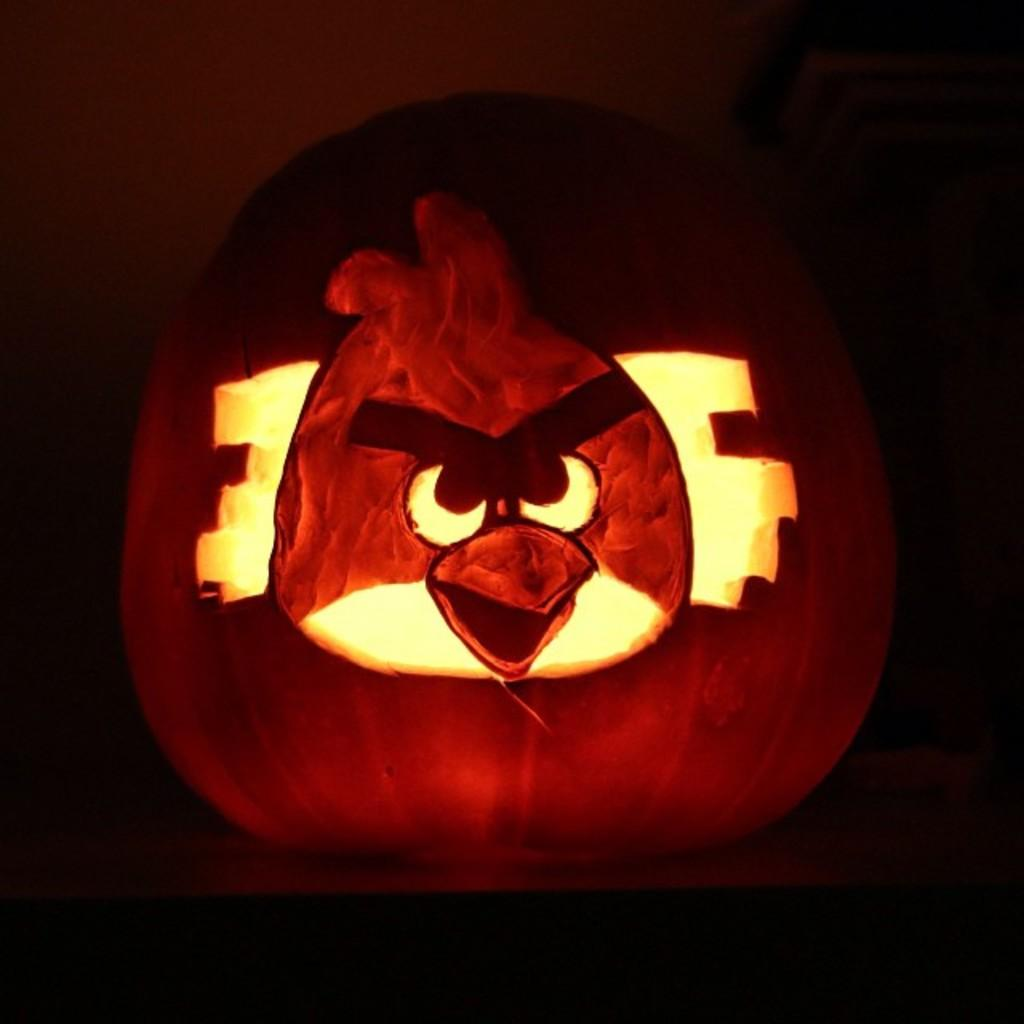What is the main object in the image? The image contains a pumpkin. What can be observed about the background of the image? The background of the image is dark. Can you tell me how many skates are visible in the image? There are no skates present in the image; it features a pumpkin against a dark background. What type of relation is depicted between the pumpkin and the background in the image? There is no relation depicted between the pumpkin and the background in the image; they are simply separate elements in the scene. 